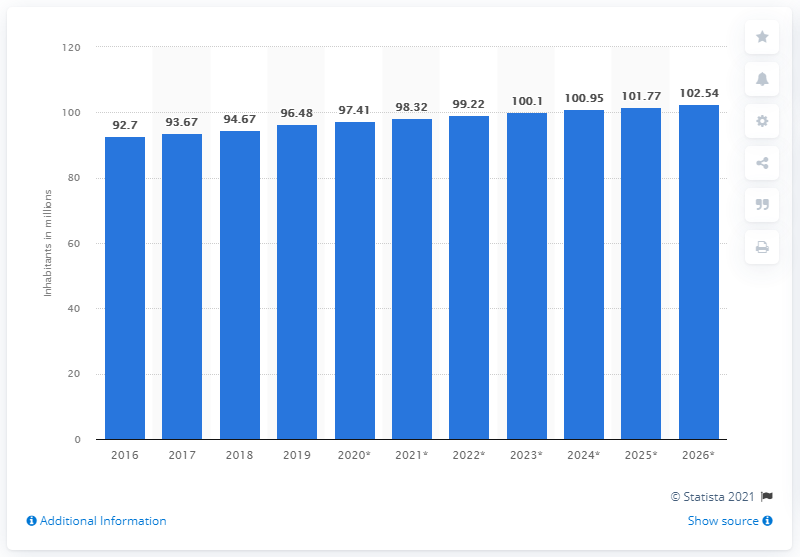Mention a couple of crucial points in this snapshot. In 2019, the population of Vietnam was 97.41 million. 